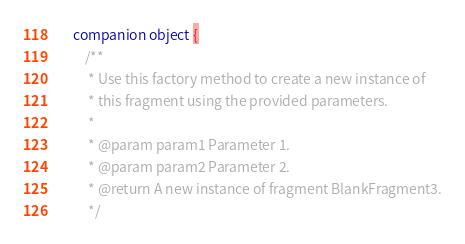<code> <loc_0><loc_0><loc_500><loc_500><_Kotlin_>    companion object {
        /**
         * Use this factory method to create a new instance of
         * this fragment using the provided parameters.
         *
         * @param param1 Parameter 1.
         * @param param2 Parameter 2.
         * @return A new instance of fragment BlankFragment3.
         */</code> 